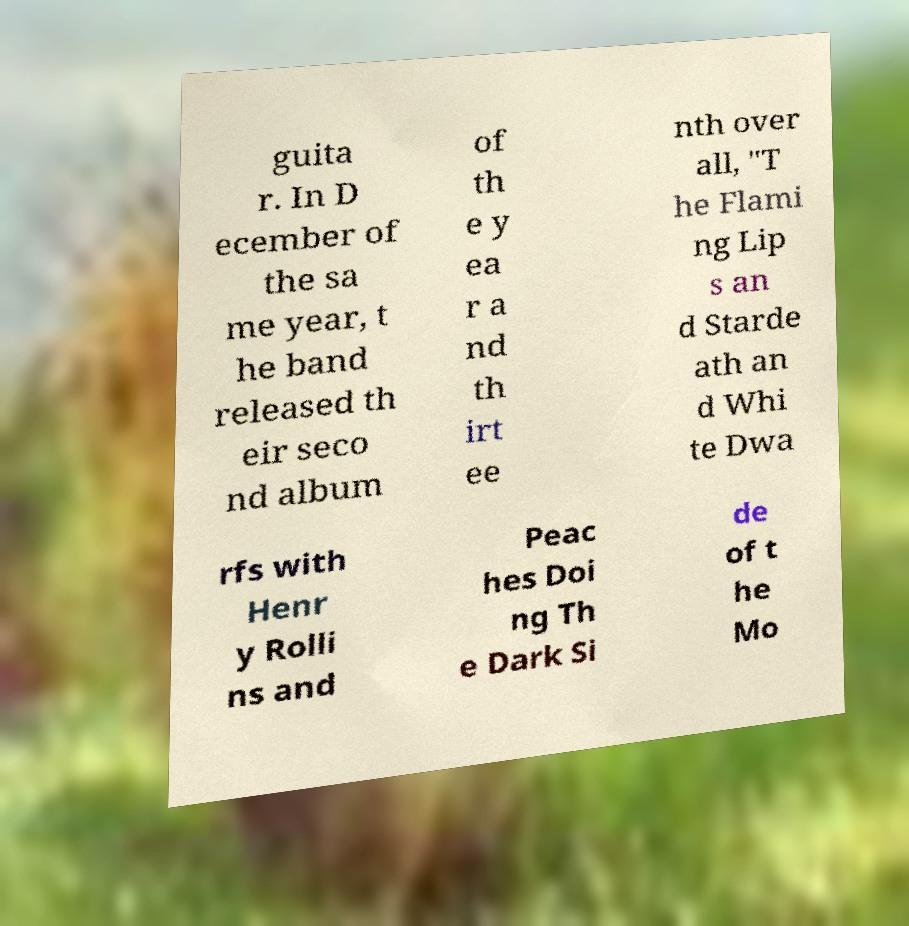For documentation purposes, I need the text within this image transcribed. Could you provide that? guita r. In D ecember of the sa me year, t he band released th eir seco nd album of th e y ea r a nd th irt ee nth over all, "T he Flami ng Lip s an d Starde ath an d Whi te Dwa rfs with Henr y Rolli ns and Peac hes Doi ng Th e Dark Si de of t he Mo 